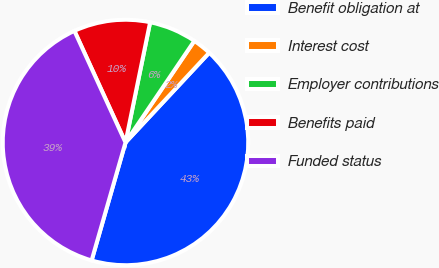<chart> <loc_0><loc_0><loc_500><loc_500><pie_chart><fcel>Benefit obligation at<fcel>Interest cost<fcel>Employer contributions<fcel>Benefits paid<fcel>Funded status<nl><fcel>42.5%<fcel>2.47%<fcel>6.26%<fcel>10.05%<fcel>38.71%<nl></chart> 